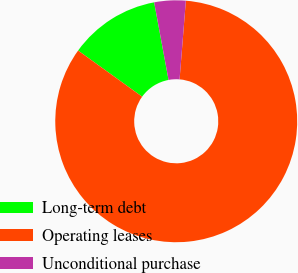Convert chart. <chart><loc_0><loc_0><loc_500><loc_500><pie_chart><fcel>Long-term debt<fcel>Operating leases<fcel>Unconditional purchase<nl><fcel>12.14%<fcel>83.67%<fcel>4.19%<nl></chart> 